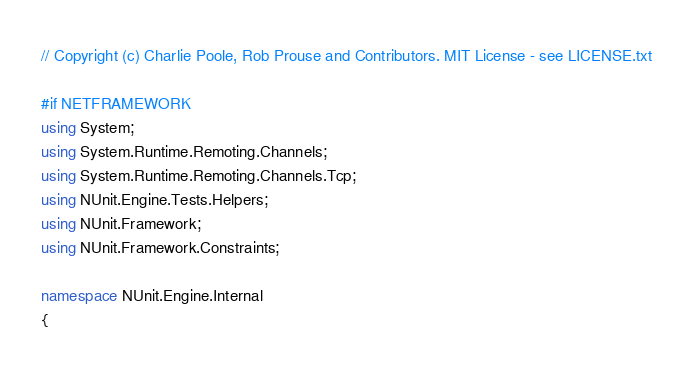Convert code to text. <code><loc_0><loc_0><loc_500><loc_500><_C#_>// Copyright (c) Charlie Poole, Rob Prouse and Contributors. MIT License - see LICENSE.txt

#if NETFRAMEWORK
using System;
using System.Runtime.Remoting.Channels;
using System.Runtime.Remoting.Channels.Tcp;
using NUnit.Engine.Tests.Helpers;
using NUnit.Framework;
using NUnit.Framework.Constraints;

namespace NUnit.Engine.Internal
{</code> 